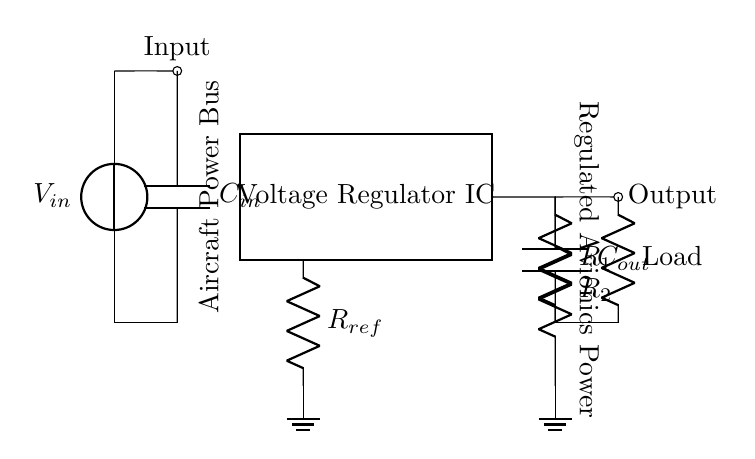What is the function of the voltage regulator IC? The voltage regulator IC is responsible for maintaining a constant output voltage despite variations in input voltage or load conditions. It ensures that the connected avionics systems receive stable power, which is critical for their proper operation.
Answer: Maintain constant output voltage What components are used in the feedback network? The feedback network consists of two resistors, R1 and R2, which are used to set the output voltage level by creating a voltage divider that feeds back a portion of the output voltage to the voltage regulator's control input.
Answer: R1 and R2 What is the purpose of the input capacitor? The input capacitor, C_in, is used to filter and stabilize the input voltage by reducing voltage spikes and noise, thus ensuring that the voltage regulator receives a clean supply for regulation.
Answer: Filter and stabilize input voltage How many external components are there in the circuit? The external components consist of the input capacitor, output capacitor, reference resistor, and feedback resistors, adding up to a total of five components besides the voltage regulator IC.
Answer: Five What does the load represent in the circuit? The load represents the avionics systems or devices that draw power from the regulated voltage supplied by the voltage regulator, indicating where the regulated output is utilized in the aircraft.
Answer: Avionics systems Why is the reference resistor important in this circuit? The reference resistor, R_ref, sets the reference voltage level for the voltage regulator, ensuring that the output voltage is maintained at the desired level by providing a stable reference point that the regulator can use for feedback comparison.
Answer: Set reference voltage level 